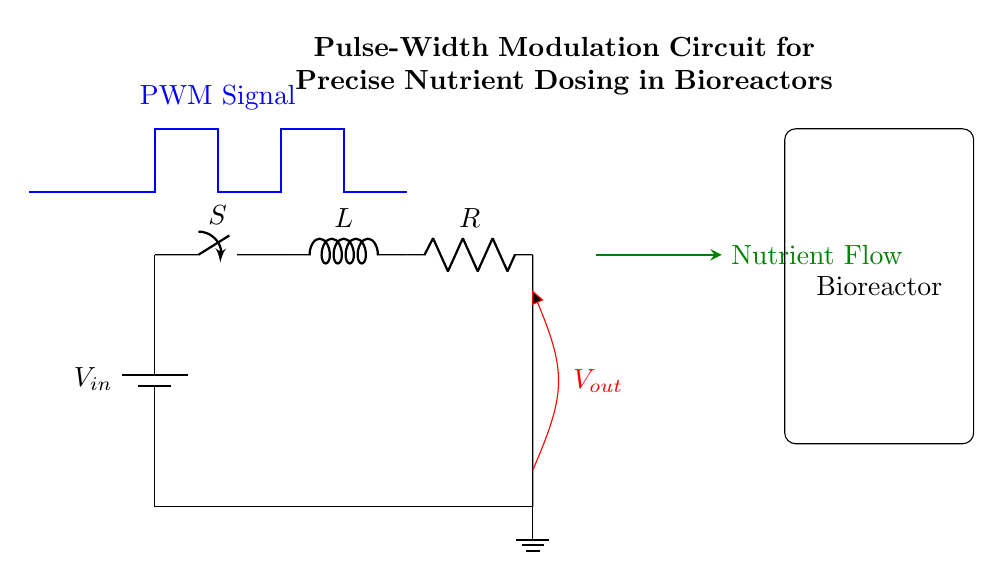What type of switch is used in this circuit? The circuit uses a switch labeled 'S', indicating it can be an on/off switch for controlling the flow of current.
Answer: Switch What are the two passive components in this circuit? The components include an inductor labeled 'L' and a resistor labeled 'R', which are both common passive components used in circuits to resist current and store energy, respectively.
Answer: Inductor and Resistor What does the PWM signal control in this circuit? The PWM signal modulates the width of the pulses, allowing for precise control of the output voltage to manage nutrient dosing effectively in the bioreactor.
Answer: Output voltage How does the circuit achieve nutrient flow? The output voltage is applied to the nutrient flow component, marked in green, which regulates the flow based on the PWM modulation.
Answer: Through output voltage control What is the purpose of the inductor in this circuit? The inductor helps to smooth out the changes in current, thus contributing to a stable output voltage when combined with the resistor and PWM signal.
Answer: Smoothing current changes What will happen if the resistance value 'R' is increased? Increasing resistance will decrease the current flow through the circuit, which will affect the output voltage and potentially reduce the nutrient supply to the bioreactor.
Answer: Current decrease What does the red line represent in this circuit? The red line indicates the output voltage, showing where voltage is measured and supplied to control the connected component in the bioreactor.
Answer: Output voltage 